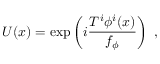Convert formula to latex. <formula><loc_0><loc_0><loc_500><loc_500>U ( x ) = \exp \left ( i \frac { T ^ { i } \phi ^ { i } ( x ) } { f _ { \phi } } \right ) ,</formula> 